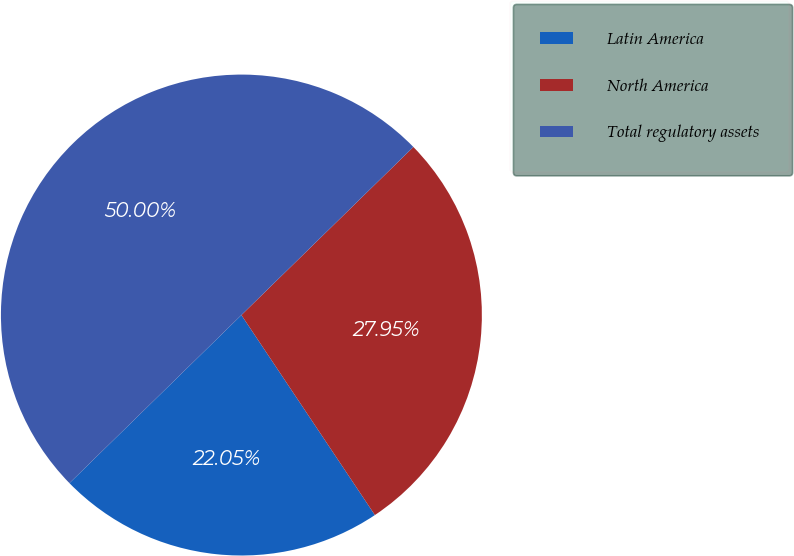<chart> <loc_0><loc_0><loc_500><loc_500><pie_chart><fcel>Latin America<fcel>North America<fcel>Total regulatory assets<nl><fcel>22.05%<fcel>27.95%<fcel>50.0%<nl></chart> 